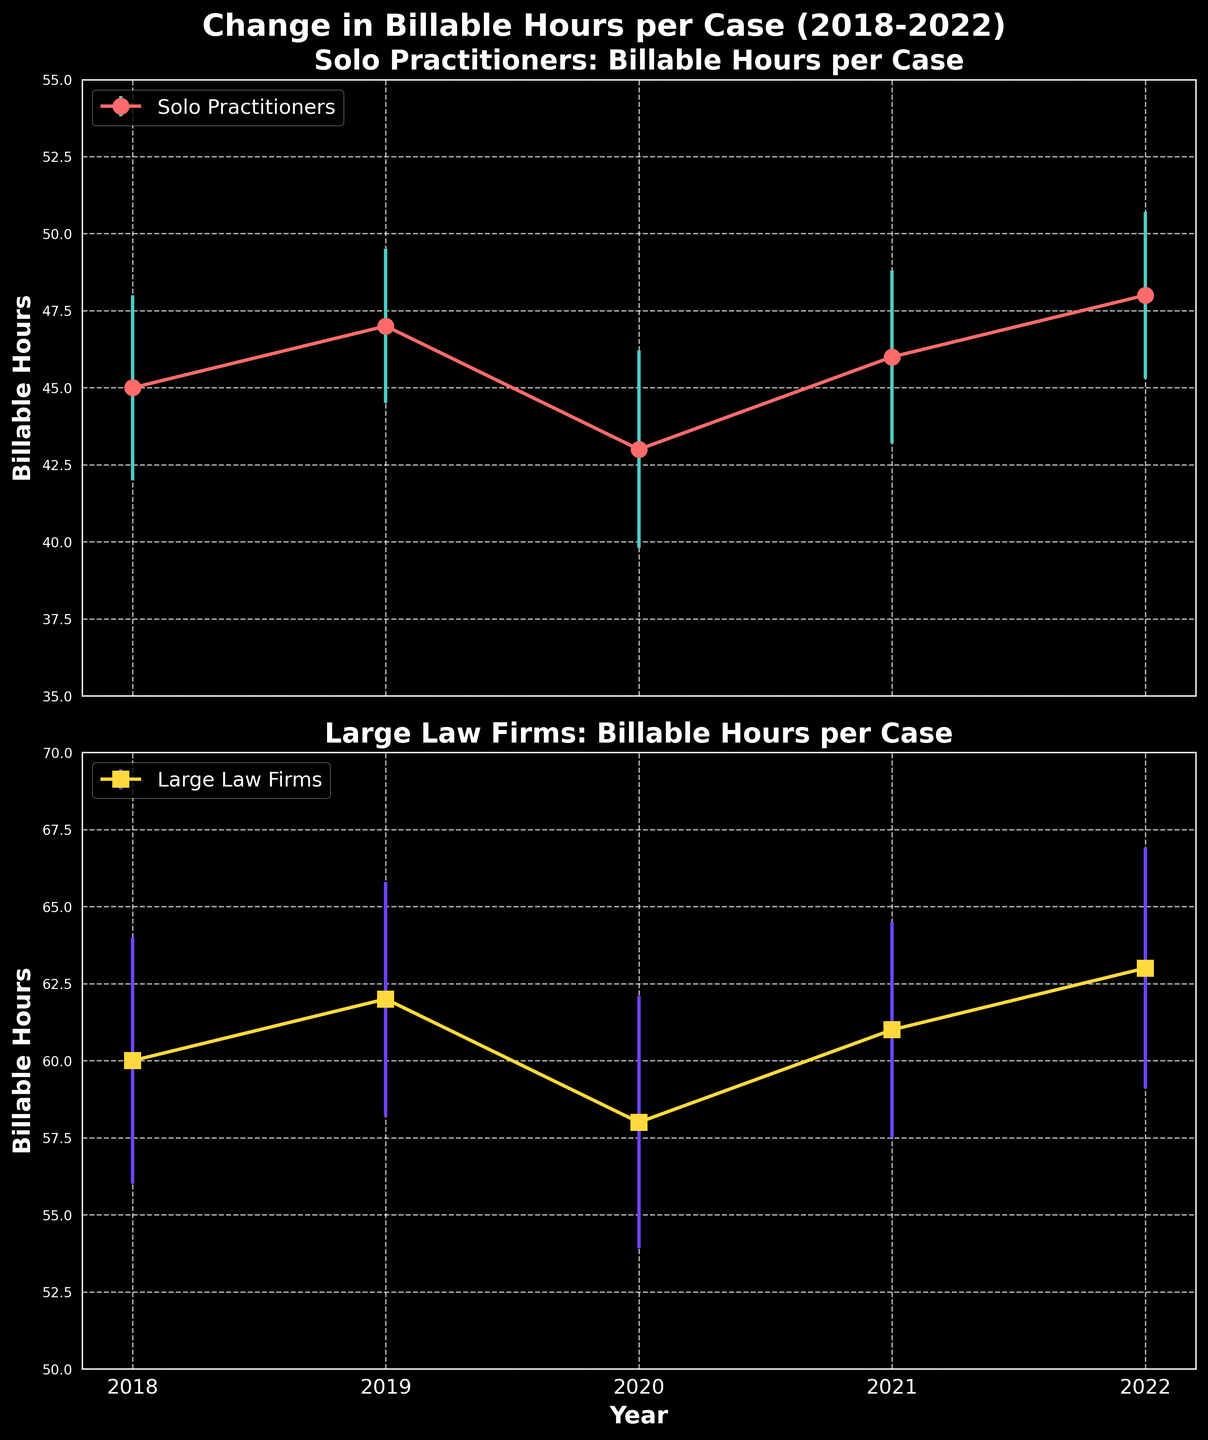Which group has higher billable hours in 2022? Look at the data points for 2022 in both subplots. Compare the billable hours for Solo Practitioners and Large Law Firms.
Answer: Large Law Firms What is the trend for billable hours for Solo Practitioners from 2018 to 2022? Examine the data points for Solo Practitioners across the years. Identify whether the values increase, decrease, or oscillate.
Answer: Increasing By how much did the billable hours for Large Law Firms decrease from 2019 to 2020? Subtract the billable hours in 2020 from those in 2019 for Large Law Firms.
Answer: 4 hours What was the error margin for Solo Practitioners in 2018? Locate the error bar value for Solo Practitioners in the 2018 data point.
Answer: 3 hours On average, which group shows a more stable (less variable) trend in billable hours over these years? Calculate the average error margin for both groups across the years and compare them. Solo Practitioners' error margins are 3, 2.5, 3.2, 2.8, 2.7, which averages to 2.84. Large Law Firms' error margins are 4, 3.8, 4.1, 3.5, 3.9, which averages to 3.86. Therefore, Solo Practitioners have a more stable trend.
Answer: Solo Practitioners What is the difference in billable hours between Solo Practitioners and Large Law Firms in 2019? Subtract the billable hours of Solo Practitioners from those of Large Law Firms for the year 2019.
Answer: 15 hours Which year had the lowest billable hours for Solo Practitioners? Identify the year within the Solo Practitioners subplot that has the lowest data point.
Answer: 2020 How does the variability in billable hours for Large Law Firms compare to Solo Practitioners in 2021? Compare the error margins (error bars) for both groups in 2021. Solo Practitioners have an error margin of 2.8, while Large Law Firms have 3.5.
Answer: Larger for Large Law Firms What is the total billable hours for Solo Practitioners across all years? Add the billable hours for Solo Practitioners from 2018 to 2022. 45 + 47 + 43 + 46 + 48 = 229
Answer: 229 In which year did both groups have the closest billable hours? Calculate the absolute differences in billable hours between the two groups for each year and identify the smallest difference. The differences are: 2018-15, 2019-15, 2020-15, 2021-15, 2022-15. All years have the same difference.
Answer: 2018, 2019, 2020, 2021, 2022 